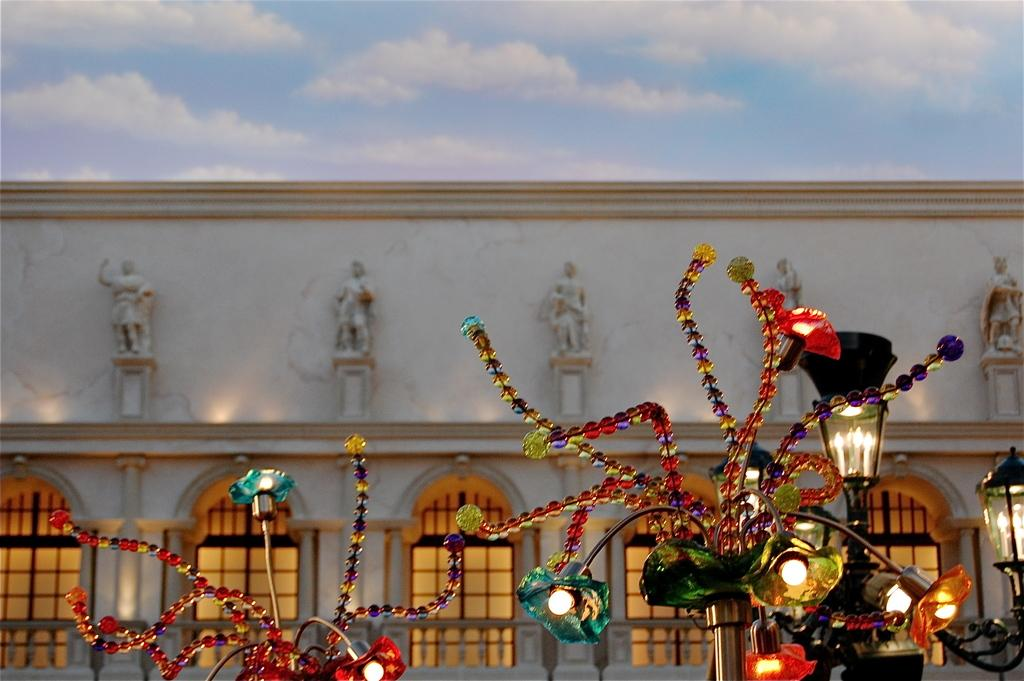What can be seen in the image that provides illumination? There are lights in the image. What other items can be seen in the image besides the lights? There are decorative objects in the image. What is visible in the background of the image? There is a building and the sky in the background of the image. What can be observed in the sky in the image? Clouds are present in the sky. Where is the maid sleeping in the image? There is no maid or sleeping person present in the image. What type of tin object can be seen in the image? There is no tin object present in the image. 